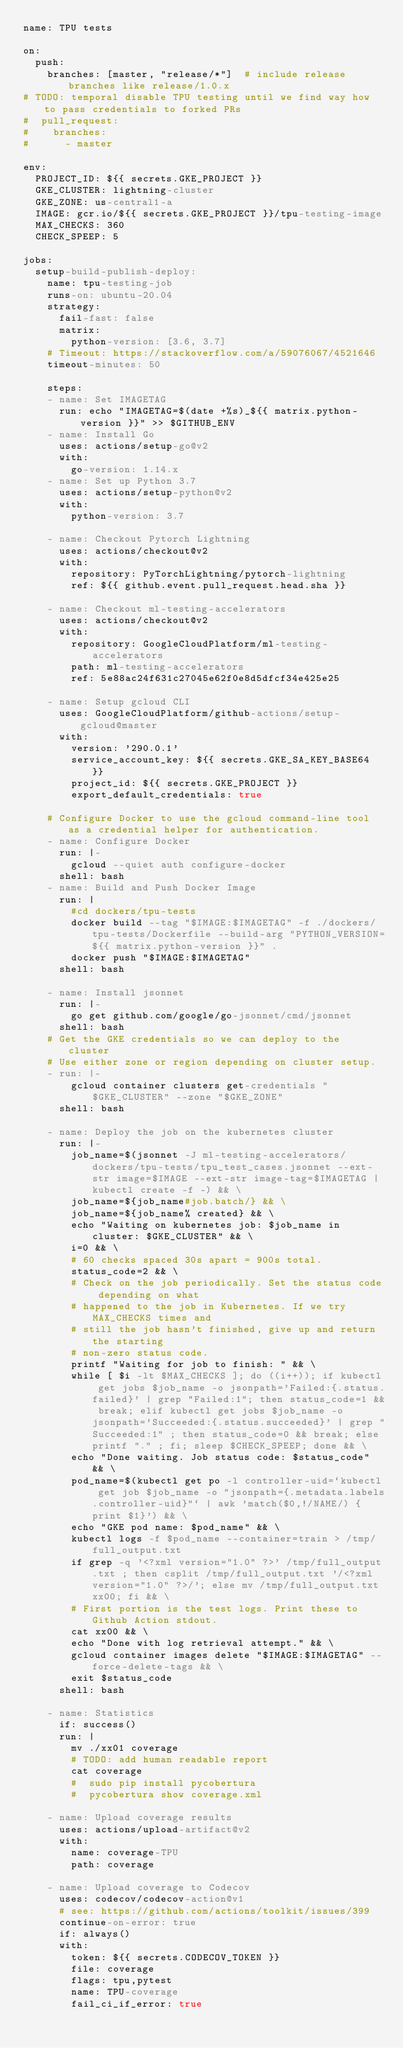Convert code to text. <code><loc_0><loc_0><loc_500><loc_500><_YAML_>name: TPU tests

on:
  push:
    branches: [master, "release/*"]  # include release branches like release/1.0.x
# TODO: temporal disable TPU testing until we find way how to pass credentials to forked PRs
#  pull_request:
#    branches:
#      - master

env:
  PROJECT_ID: ${{ secrets.GKE_PROJECT }}
  GKE_CLUSTER: lightning-cluster
  GKE_ZONE: us-central1-a
  IMAGE: gcr.io/${{ secrets.GKE_PROJECT }}/tpu-testing-image
  MAX_CHECKS: 360
  CHECK_SPEEP: 5

jobs:
  setup-build-publish-deploy:
    name: tpu-testing-job
    runs-on: ubuntu-20.04
    strategy:
      fail-fast: false
      matrix:
        python-version: [3.6, 3.7]
    # Timeout: https://stackoverflow.com/a/59076067/4521646
    timeout-minutes: 50

    steps:
    - name: Set IMAGETAG
      run: echo "IMAGETAG=$(date +%s)_${{ matrix.python-version }}" >> $GITHUB_ENV
    - name: Install Go
      uses: actions/setup-go@v2
      with:
        go-version: 1.14.x
    - name: Set up Python 3.7
      uses: actions/setup-python@v2
      with:
        python-version: 3.7

    - name: Checkout Pytorch Lightning
      uses: actions/checkout@v2
      with:
        repository: PyTorchLightning/pytorch-lightning
        ref: ${{ github.event.pull_request.head.sha }}

    - name: Checkout ml-testing-accelerators
      uses: actions/checkout@v2
      with:
        repository: GoogleCloudPlatform/ml-testing-accelerators
        path: ml-testing-accelerators
        ref: 5e88ac24f631c27045e62f0e8d5dfcf34e425e25

    - name: Setup gcloud CLI
      uses: GoogleCloudPlatform/github-actions/setup-gcloud@master
      with:
        version: '290.0.1'
        service_account_key: ${{ secrets.GKE_SA_KEY_BASE64 }}
        project_id: ${{ secrets.GKE_PROJECT }}
        export_default_credentials: true

    # Configure Docker to use the gcloud command-line tool as a credential helper for authentication.
    - name: Configure Docker
      run: |-
        gcloud --quiet auth configure-docker
      shell: bash
    - name: Build and Push Docker Image
      run: |
        #cd dockers/tpu-tests
        docker build --tag "$IMAGE:$IMAGETAG" -f ./dockers/tpu-tests/Dockerfile --build-arg "PYTHON_VERSION=${{ matrix.python-version }}" .
        docker push "$IMAGE:$IMAGETAG"
      shell: bash

    - name: Install jsonnet
      run: |-
        go get github.com/google/go-jsonnet/cmd/jsonnet
      shell: bash
    # Get the GKE credentials so we can deploy to the cluster
    # Use either zone or region depending on cluster setup.
    - run: |-
        gcloud container clusters get-credentials "$GKE_CLUSTER" --zone "$GKE_ZONE"
      shell: bash

    - name: Deploy the job on the kubernetes cluster
      run: |-
        job_name=$(jsonnet -J ml-testing-accelerators/ dockers/tpu-tests/tpu_test_cases.jsonnet --ext-str image=$IMAGE --ext-str image-tag=$IMAGETAG | kubectl create -f -) && \
        job_name=${job_name#job.batch/} && \
        job_name=${job_name% created} && \
        echo "Waiting on kubernetes job: $job_name in cluster: $GKE_CLUSTER" && \
        i=0 && \
        # 60 checks spaced 30s apart = 900s total.
        status_code=2 && \
        # Check on the job periodically. Set the status code depending on what
        # happened to the job in Kubernetes. If we try MAX_CHECKS times and
        # still the job hasn't finished, give up and return the starting
        # non-zero status code.
        printf "Waiting for job to finish: " && \
        while [ $i -lt $MAX_CHECKS ]; do ((i++)); if kubectl get jobs $job_name -o jsonpath='Failed:{.status.failed}' | grep "Failed:1"; then status_code=1 && break; elif kubectl get jobs $job_name -o jsonpath='Succeeded:{.status.succeeded}' | grep "Succeeded:1" ; then status_code=0 && break; else printf "." ; fi; sleep $CHECK_SPEEP; done && \
        echo "Done waiting. Job status code: $status_code" && \
        pod_name=$(kubectl get po -l controller-uid=`kubectl get job $job_name -o "jsonpath={.metadata.labels.controller-uid}"` | awk 'match($0,!/NAME/) {print $1}') && \
        echo "GKE pod name: $pod_name" && \
        kubectl logs -f $pod_name --container=train > /tmp/full_output.txt
        if grep -q '<?xml version="1.0" ?>' /tmp/full_output.txt ; then csplit /tmp/full_output.txt '/<?xml version="1.0" ?>/'; else mv /tmp/full_output.txt xx00; fi && \
        # First portion is the test logs. Print these to Github Action stdout.
        cat xx00 && \
        echo "Done with log retrieval attempt." && \
        gcloud container images delete "$IMAGE:$IMAGETAG" --force-delete-tags && \
        exit $status_code
      shell: bash

    - name: Statistics
      if: success()
      run: |
        mv ./xx01 coverage
        # TODO: add human readable report
        cat coverage
        #  sudo pip install pycobertura
        #  pycobertura show coverage.xml

    - name: Upload coverage results
      uses: actions/upload-artifact@v2
      with:
        name: coverage-TPU
        path: coverage

    - name: Upload coverage to Codecov
      uses: codecov/codecov-action@v1
      # see: https://github.com/actions/toolkit/issues/399
      continue-on-error: true
      if: always()
      with:
        token: ${{ secrets.CODECOV_TOKEN }}
        file: coverage
        flags: tpu,pytest
        name: TPU-coverage
        fail_ci_if_error: true
</code> 